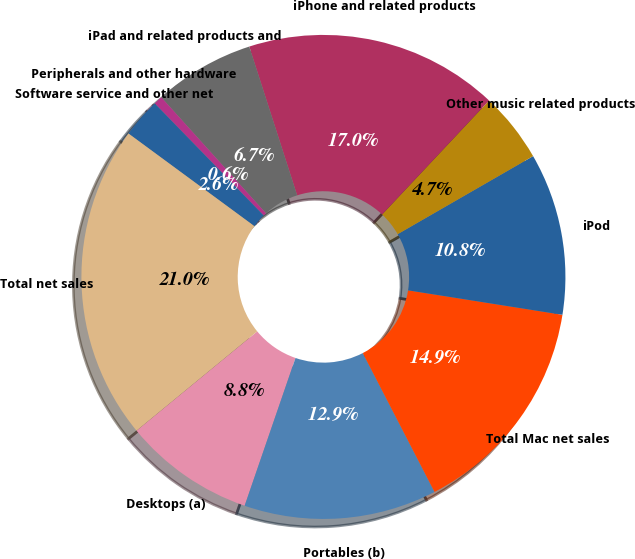<chart> <loc_0><loc_0><loc_500><loc_500><pie_chart><fcel>Desktops (a)<fcel>Portables (b)<fcel>Total Mac net sales<fcel>iPod<fcel>Other music related products<fcel>iPhone and related products<fcel>iPad and related products and<fcel>Peripherals and other hardware<fcel>Software service and other net<fcel>Total net sales<nl><fcel>8.77%<fcel>12.87%<fcel>14.91%<fcel>10.82%<fcel>4.68%<fcel>16.96%<fcel>6.73%<fcel>0.59%<fcel>2.63%<fcel>21.05%<nl></chart> 